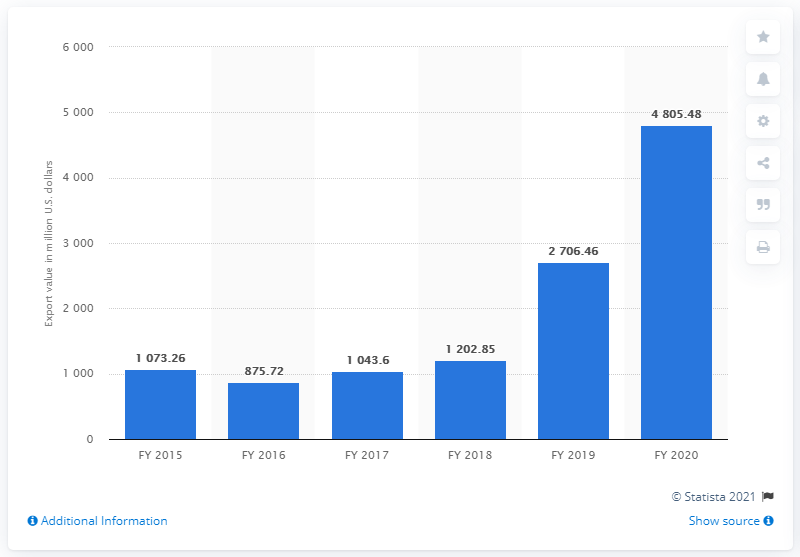List a handful of essential elements in this visual. The export value for telecommunication instruments from India at the end of fiscal year 2020 was 4805.48. 